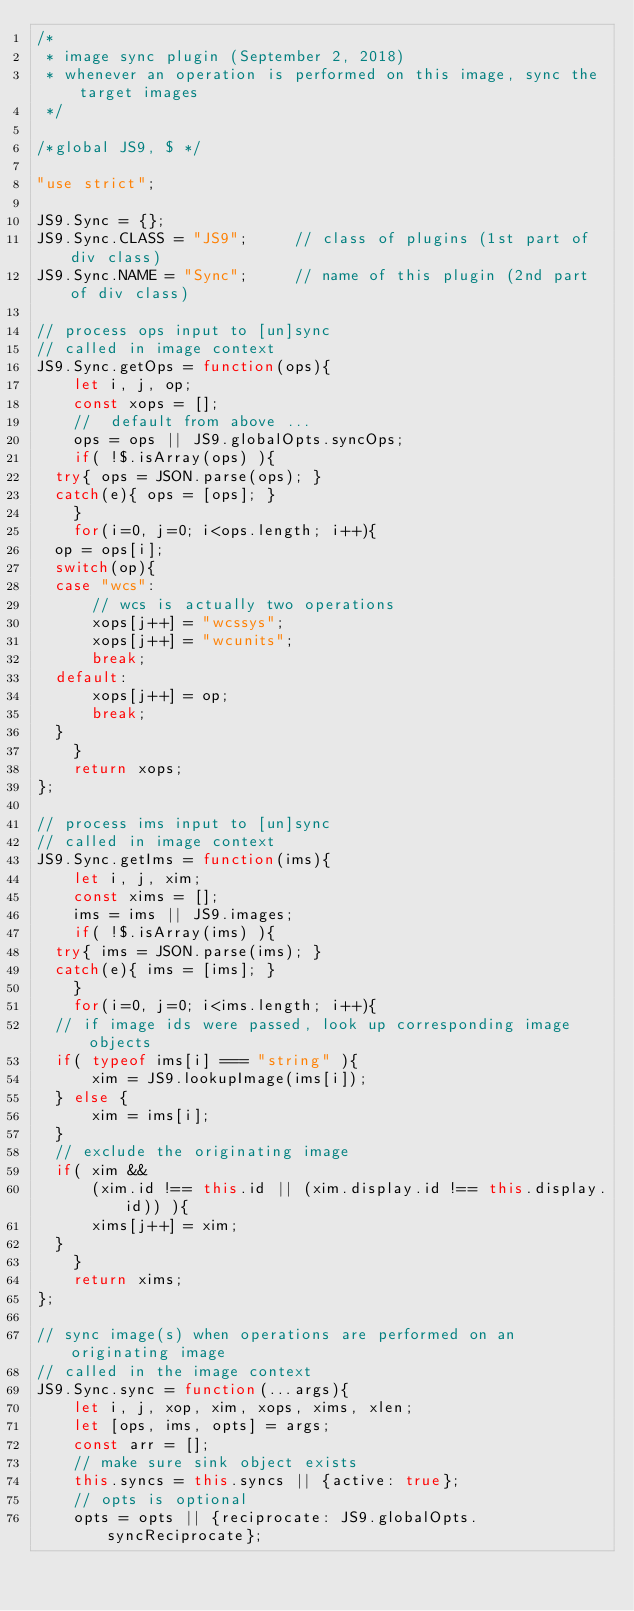<code> <loc_0><loc_0><loc_500><loc_500><_JavaScript_>/*
 * image sync plugin (September 2, 2018)
 * whenever an operation is performed on this image, sync the target images
 */

/*global JS9, $ */

"use strict";

JS9.Sync = {};
JS9.Sync.CLASS = "JS9";     // class of plugins (1st part of div class)
JS9.Sync.NAME = "Sync";     // name of this plugin (2nd part of div class)

// process ops input to [un]sync
// called in image context
JS9.Sync.getOps = function(ops){
    let i, j, op;
    const xops = [];
    //  default from above ...
    ops = ops || JS9.globalOpts.syncOps;
    if( !$.isArray(ops) ){
	try{ ops = JSON.parse(ops); }
	catch(e){ ops = [ops]; }
    }
    for(i=0, j=0; i<ops.length; i++){
	op = ops[i];
	switch(op){
	case "wcs":
	    // wcs is actually two operations
	    xops[j++] = "wcssys";
	    xops[j++] = "wcunits";
	    break;
	default:
	    xops[j++] = op;
	    break;
	}
    }
    return xops;
};

// process ims input to [un]sync
// called in image context
JS9.Sync.getIms = function(ims){
    let i, j, xim;
    const xims = [];
    ims = ims || JS9.images;
    if( !$.isArray(ims) ){
	try{ ims = JSON.parse(ims); }
	catch(e){ ims = [ims]; }
    }
    for(i=0, j=0; i<ims.length; i++){
	// if image ids were passed, look up corresponding image objects
	if( typeof ims[i] === "string" ){
	    xim = JS9.lookupImage(ims[i]);
	} else {
	    xim = ims[i];
	}
	// exclude the originating image
	if( xim &&
	    (xim.id !== this.id || (xim.display.id !== this.display.id)) ){
	    xims[j++] = xim;
	}
    }
    return xims;
};

// sync image(s) when operations are performed on an originating image
// called in the image context
JS9.Sync.sync = function(...args){
    let i, j, xop, xim, xops, xims, xlen;
    let [ops, ims, opts] = args;
    const arr = [];
    // make sure sink object exists
    this.syncs = this.syncs || {active: true};
    // opts is optional
    opts = opts || {reciprocate: JS9.globalOpts.syncReciprocate};</code> 